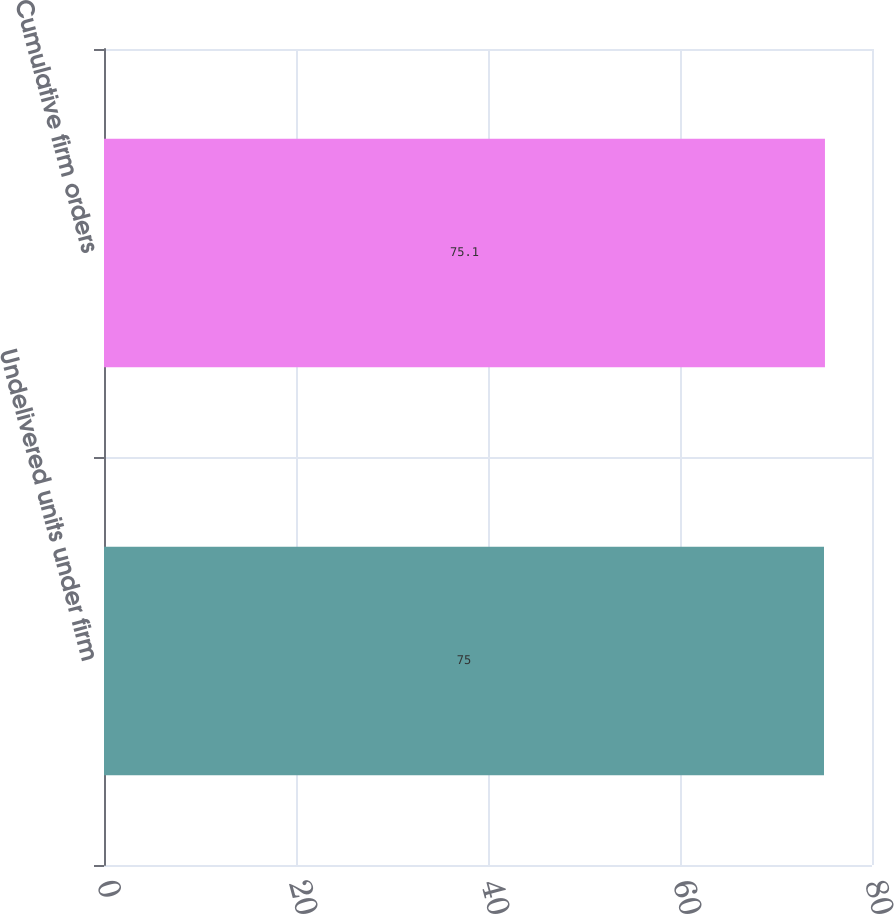Convert chart to OTSL. <chart><loc_0><loc_0><loc_500><loc_500><bar_chart><fcel>Undelivered units under firm<fcel>Cumulative firm orders<nl><fcel>75<fcel>75.1<nl></chart> 